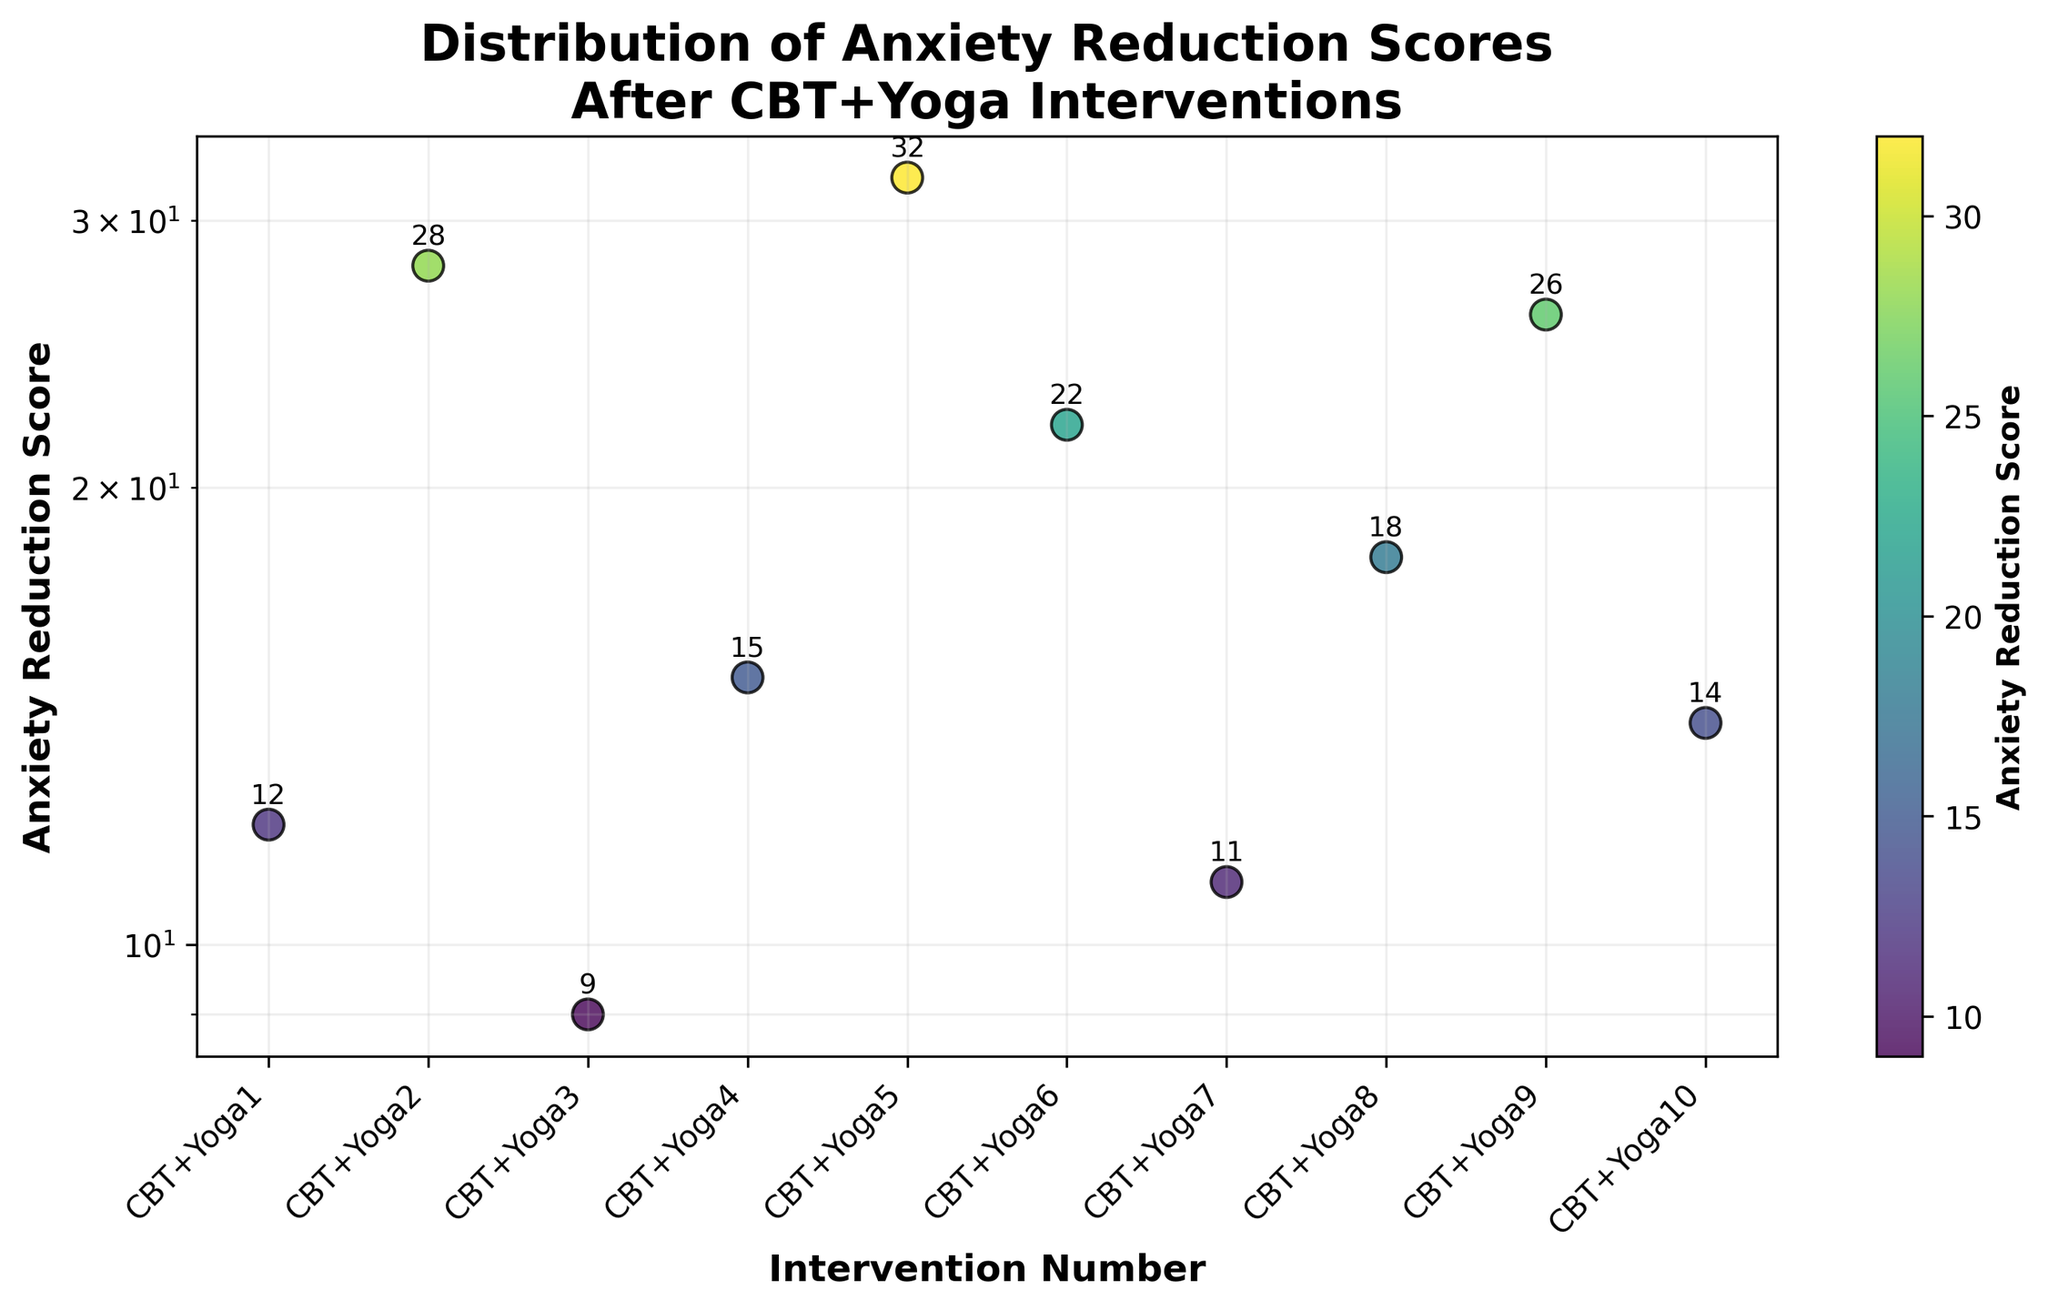What is the title of the figure? The title is written prominently at the top of the figure. It describes the plot’s content.
Answer: Distribution of Anxiety Reduction Scores After CBT+Yoga Interventions How many interventions are depicted in the plot? The plot has data points for each intervention. Count them to get the total number.
Answer: 10 What is the axis label for the y-axis? The label for the y-axis is clearly marked and indicates what the y-values represent.
Answer: Anxiety Reduction Score Which intervention has the highest Anxiety Reduction Score? Observe the data points and identify the highest score.
Answer: CBT+Yoga5 What is the intervention number for the lowest Anxiety Reduction Score? Identify the smallest y-value and refer to the corresponding x-value, which represents the intervention number.
Answer: 3 What is the median Anxiety Reduction Score across all interventions? Arrange the scores in numerical order and find the middle value. With 10 interventions, the median is the average of the 5th and 6th scores.
Answer: 14.5 Which intervention shows an Anxiety Reduction Score closest to the median value? Compare each score to the median score calculated in the previous question, and find the one that has the least difference.
Answer: CBT+Yoga10 What is the difference in Anxiety Reduction Scores between CBT+Yoga2 and CBT+Yoga3? Subtract the score of CBT+Yoga3 from the score of CBT+Yoga2.
Answer: 19 How does the log scale on the y-axis affect the perception of differences in Anxiety Reduction Scores? The log scale compresses larger values and expands smaller values, which can make differences in lower scores appear more pronounced.
Answer: Differences in lower scores appear larger Which interventions have Anxiety Reduction Scores greater than 20? Identify all data points that have a value above 20 on the y-axis.
Answer: CBT+Yoga2, CBT+Yoga5, CBT+Yoga6, CBT+Yoga9 